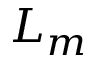<formula> <loc_0><loc_0><loc_500><loc_500>L _ { m }</formula> 